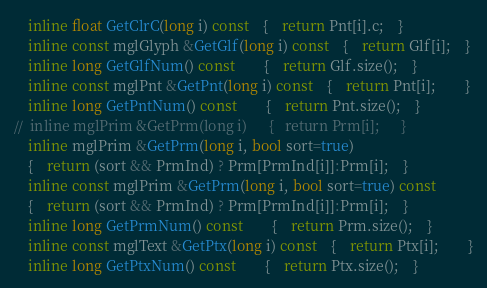<code> <loc_0><loc_0><loc_500><loc_500><_C_>	inline float GetClrC(long i) const	{	return Pnt[i].c;	}
	inline const mglGlyph &GetGlf(long i) const	{	return Glf[i];	}
	inline long GetGlfNum() const		{	return Glf.size();	}
	inline const mglPnt &GetPnt(long i) const	{	return Pnt[i];		}
	inline long GetPntNum() const		{	return Pnt.size();	}
//	inline mglPrim &GetPrm(long i)		{	return Prm[i];		}
	inline mglPrim &GetPrm(long i, bool sort=true)
	{	return (sort && PrmInd) ? Prm[PrmInd[i]]:Prm[i];	}
	inline const mglPrim &GetPrm(long i, bool sort=true) const
	{	return (sort && PrmInd) ? Prm[PrmInd[i]]:Prm[i];	}
	inline long GetPrmNum() const		{	return Prm.size();	}
	inline const mglText &GetPtx(long i) const	{	return Ptx[i];		}
	inline long GetPtxNum() const		{	return Ptx.size();	}</code> 